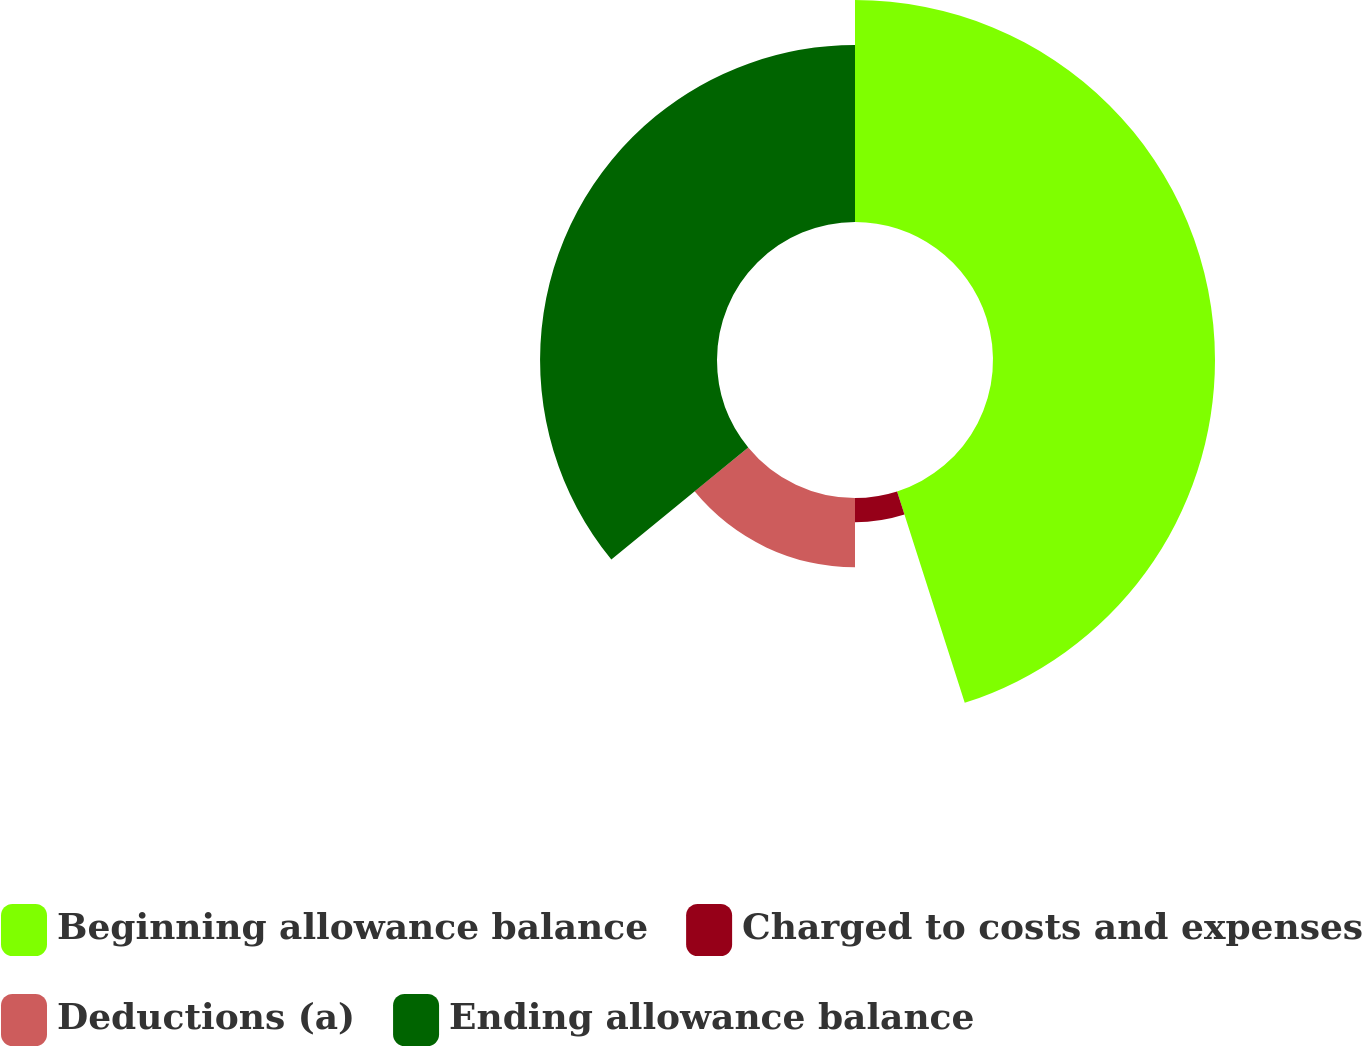Convert chart. <chart><loc_0><loc_0><loc_500><loc_500><pie_chart><fcel>Beginning allowance balance<fcel>Charged to costs and expenses<fcel>Deductions (a)<fcel>Ending allowance balance<nl><fcel>45.07%<fcel>4.93%<fcel>14.08%<fcel>35.92%<nl></chart> 